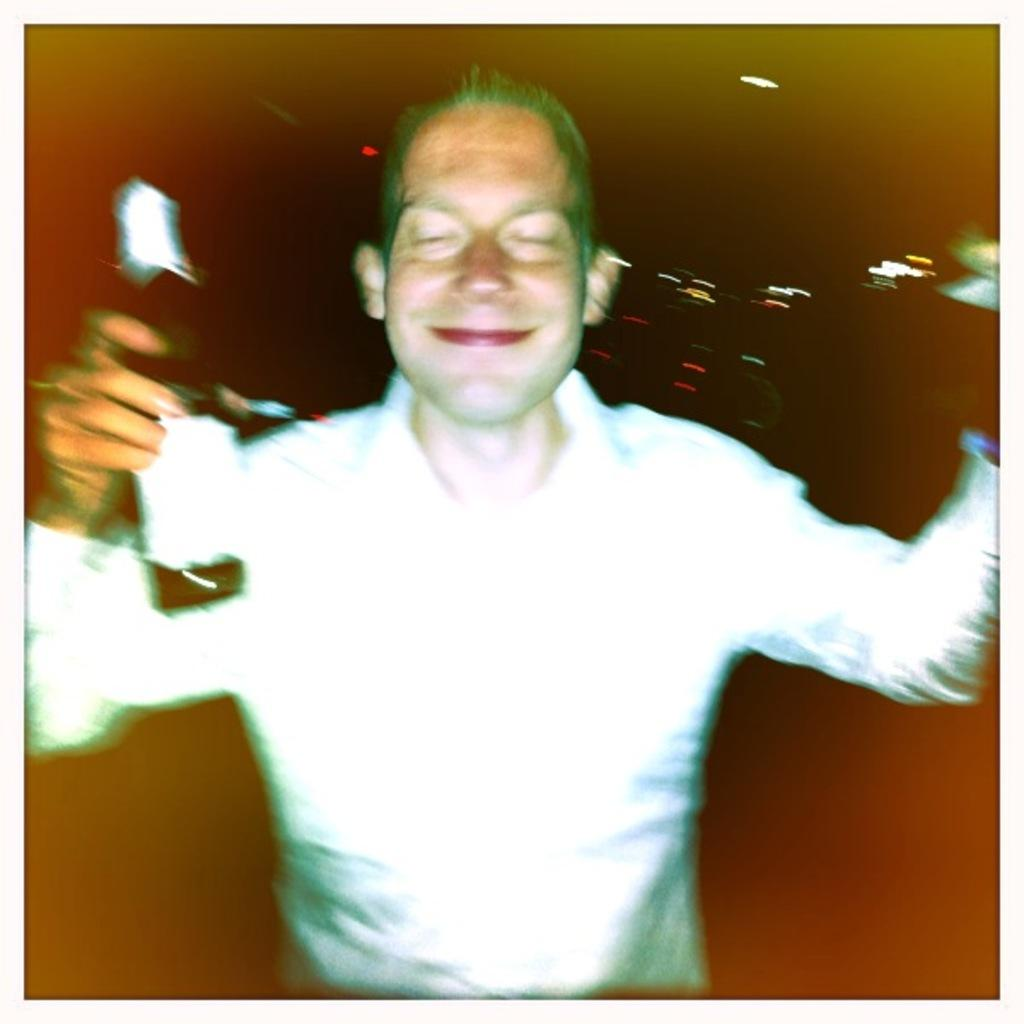Who is present in the image? There is a man in the image. What is the man holding in the image? The man is holding a bottle. What can be observed about the background of the image? The background of the image is dark. What else can be seen in the image besides the man and the bottle? Lights are present in the image. Where is the cannon located in the image? There is no cannon present in the image. What type of club is the man holding in the image? The man is not holding a club; he is holding a bottle. 